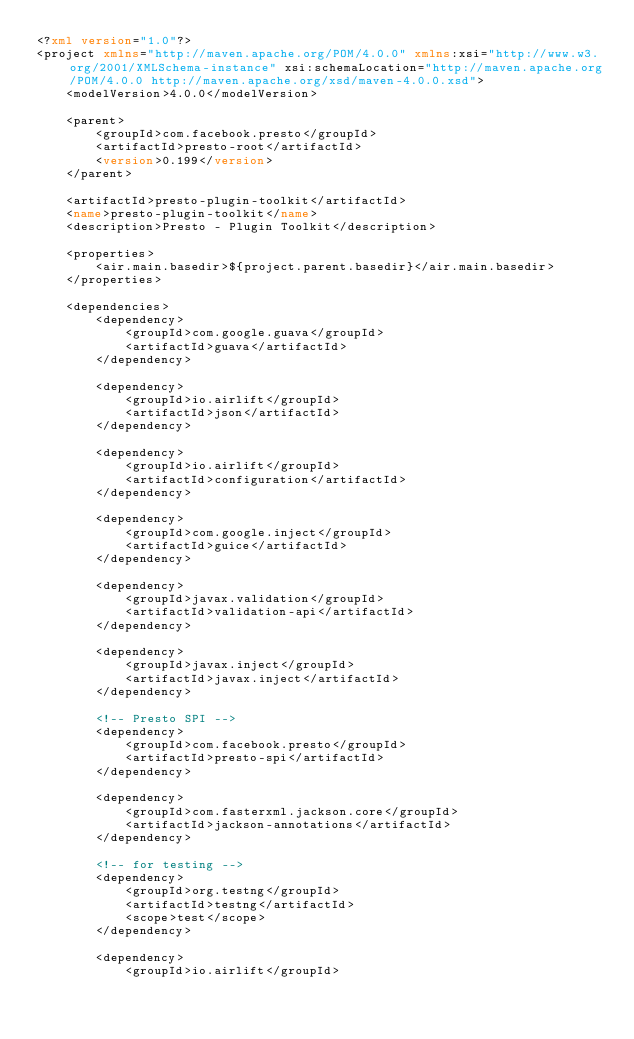Convert code to text. <code><loc_0><loc_0><loc_500><loc_500><_XML_><?xml version="1.0"?>
<project xmlns="http://maven.apache.org/POM/4.0.0" xmlns:xsi="http://www.w3.org/2001/XMLSchema-instance" xsi:schemaLocation="http://maven.apache.org/POM/4.0.0 http://maven.apache.org/xsd/maven-4.0.0.xsd">
    <modelVersion>4.0.0</modelVersion>

    <parent>
        <groupId>com.facebook.presto</groupId>
        <artifactId>presto-root</artifactId>
        <version>0.199</version>
    </parent>

    <artifactId>presto-plugin-toolkit</artifactId>
    <name>presto-plugin-toolkit</name>
    <description>Presto - Plugin Toolkit</description>

    <properties>
        <air.main.basedir>${project.parent.basedir}</air.main.basedir>
    </properties>

    <dependencies>
        <dependency>
            <groupId>com.google.guava</groupId>
            <artifactId>guava</artifactId>
        </dependency>

        <dependency>
            <groupId>io.airlift</groupId>
            <artifactId>json</artifactId>
        </dependency>

        <dependency>
            <groupId>io.airlift</groupId>
            <artifactId>configuration</artifactId>
        </dependency>

        <dependency>
            <groupId>com.google.inject</groupId>
            <artifactId>guice</artifactId>
        </dependency>

        <dependency>
            <groupId>javax.validation</groupId>
            <artifactId>validation-api</artifactId>
        </dependency>

        <dependency>
            <groupId>javax.inject</groupId>
            <artifactId>javax.inject</artifactId>
        </dependency>

        <!-- Presto SPI -->
        <dependency>
            <groupId>com.facebook.presto</groupId>
            <artifactId>presto-spi</artifactId>
        </dependency>

        <dependency>
            <groupId>com.fasterxml.jackson.core</groupId>
            <artifactId>jackson-annotations</artifactId>
        </dependency>

        <!-- for testing -->
        <dependency>
            <groupId>org.testng</groupId>
            <artifactId>testng</artifactId>
            <scope>test</scope>
        </dependency>

        <dependency>
            <groupId>io.airlift</groupId></code> 